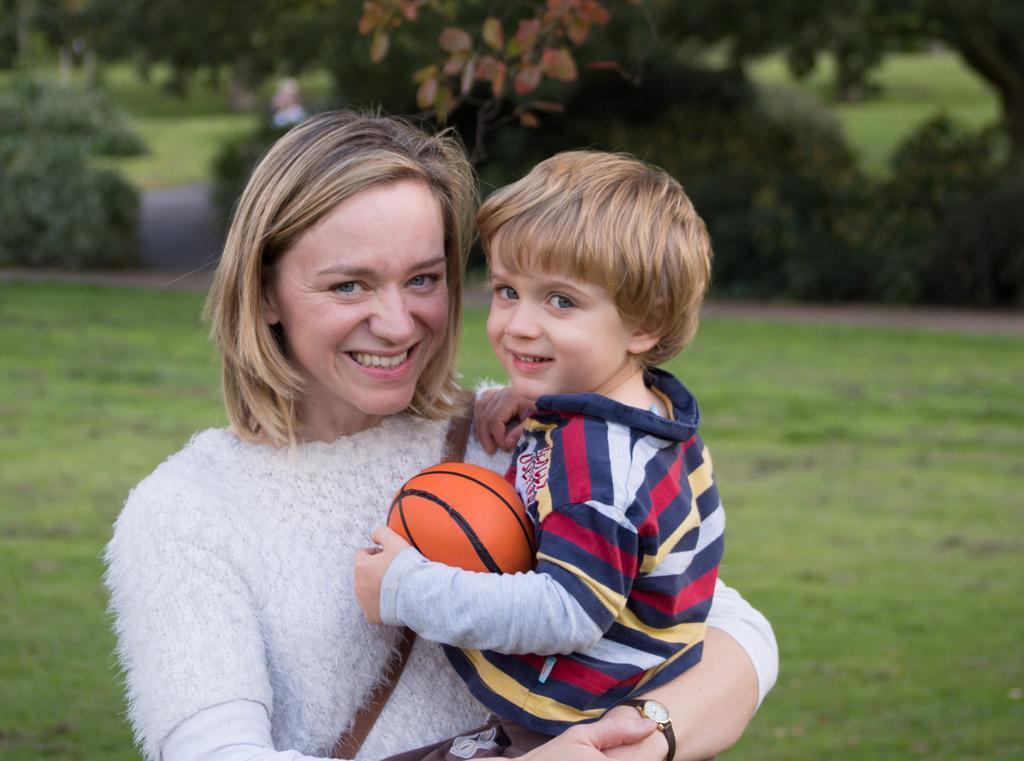Who is the main subject in the image? There is a woman in the image. What is the woman doing in the image? The woman is holding a boy. What is the boy holding in the image? The boy is holding a ball. What can be seen in the background of the image? There are trees and plants in the background of the image. What type of sidewalk can be seen in the image? There is no sidewalk present in the image. What is the boy learning to do with the ball in the image? The image does not show the boy learning to do anything with the ball; he is simply holding it. 